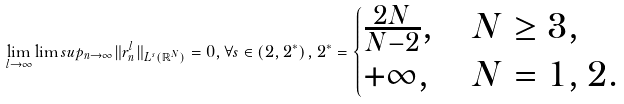<formula> <loc_0><loc_0><loc_500><loc_500>\lim _ { l \to \infty } \lim s u p _ { n \to \infty } \| r _ { n } ^ { l } \| _ { L ^ { s } ( \mathbb { R } ^ { N } ) } = 0 , \forall s \in \left ( 2 , 2 ^ { * } \right ) , 2 ^ { * } = \begin{cases} \frac { 2 N } { N - 2 } , & N \geq 3 , \\ + \infty , & N = 1 , 2 . \end{cases}</formula> 